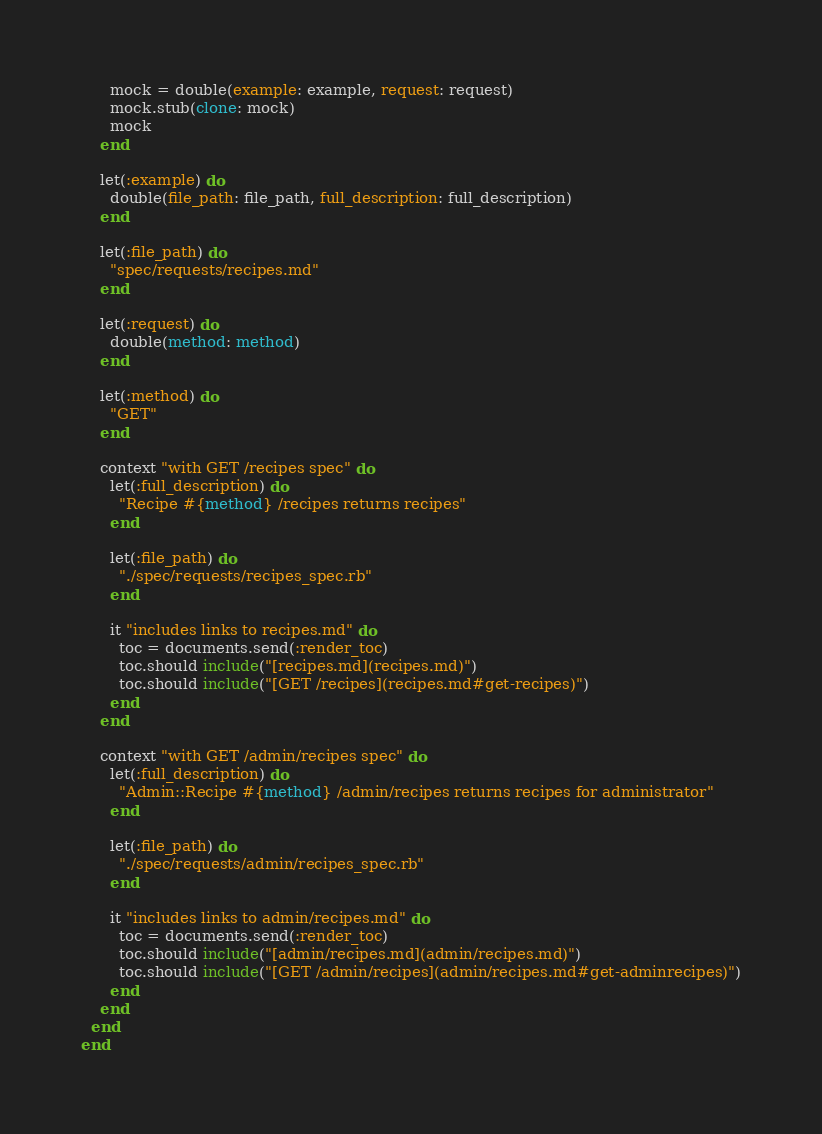Convert code to text. <code><loc_0><loc_0><loc_500><loc_500><_Ruby_>      mock = double(example: example, request: request)
      mock.stub(clone: mock)
      mock
    end

    let(:example) do
      double(file_path: file_path, full_description: full_description)
    end

    let(:file_path) do
      "spec/requests/recipes.md"
    end

    let(:request) do
      double(method: method)
    end

    let(:method) do
      "GET"
    end

    context "with GET /recipes spec" do
      let(:full_description) do
        "Recipe #{method} /recipes returns recipes"
      end

      let(:file_path) do
        "./spec/requests/recipes_spec.rb"
      end

      it "includes links to recipes.md" do
        toc = documents.send(:render_toc)
        toc.should include("[recipes.md](recipes.md)")
        toc.should include("[GET /recipes](recipes.md#get-recipes)")
      end
    end

    context "with GET /admin/recipes spec" do
      let(:full_description) do
        "Admin::Recipe #{method} /admin/recipes returns recipes for administrator"
      end

      let(:file_path) do
        "./spec/requests/admin/recipes_spec.rb"
      end

      it "includes links to admin/recipes.md" do
        toc = documents.send(:render_toc)
        toc.should include("[admin/recipes.md](admin/recipes.md)")
        toc.should include("[GET /admin/recipes](admin/recipes.md#get-adminrecipes)")
      end
    end
  end
end
</code> 